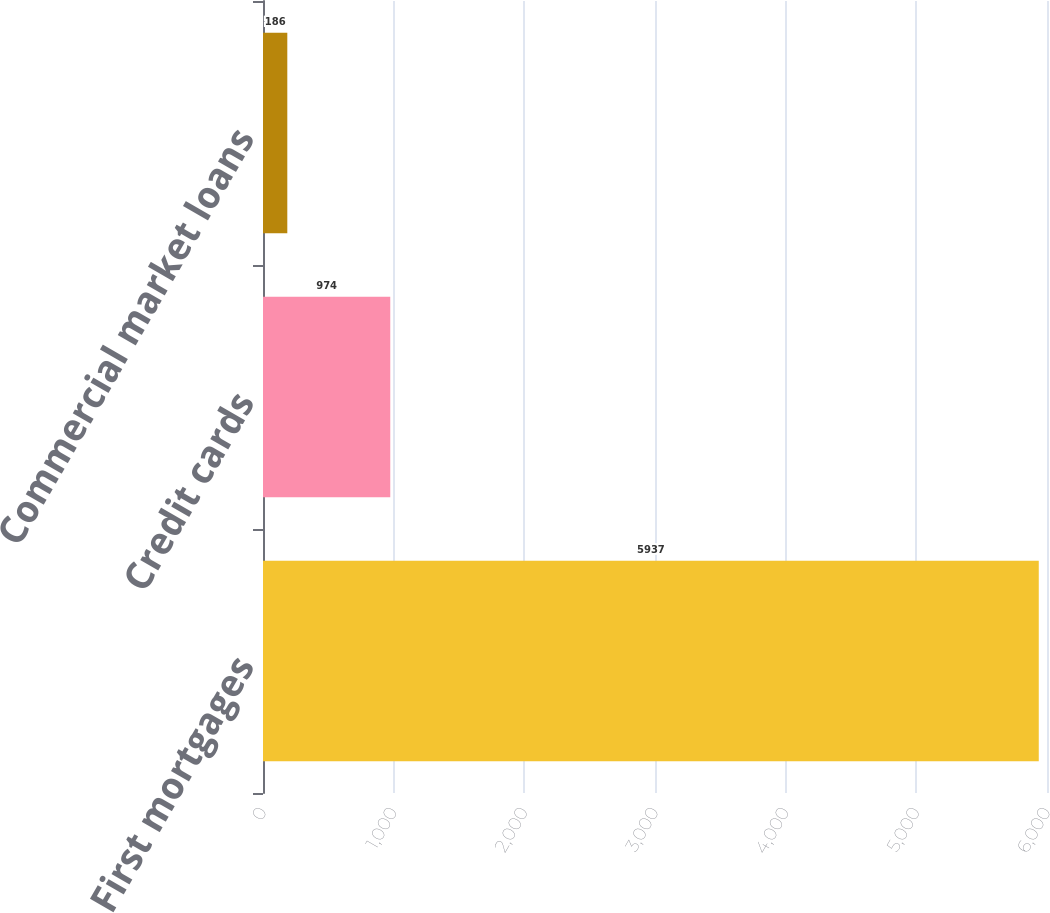<chart> <loc_0><loc_0><loc_500><loc_500><bar_chart><fcel>First mortgages<fcel>Credit cards<fcel>Commercial market loans<nl><fcel>5937<fcel>974<fcel>186<nl></chart> 